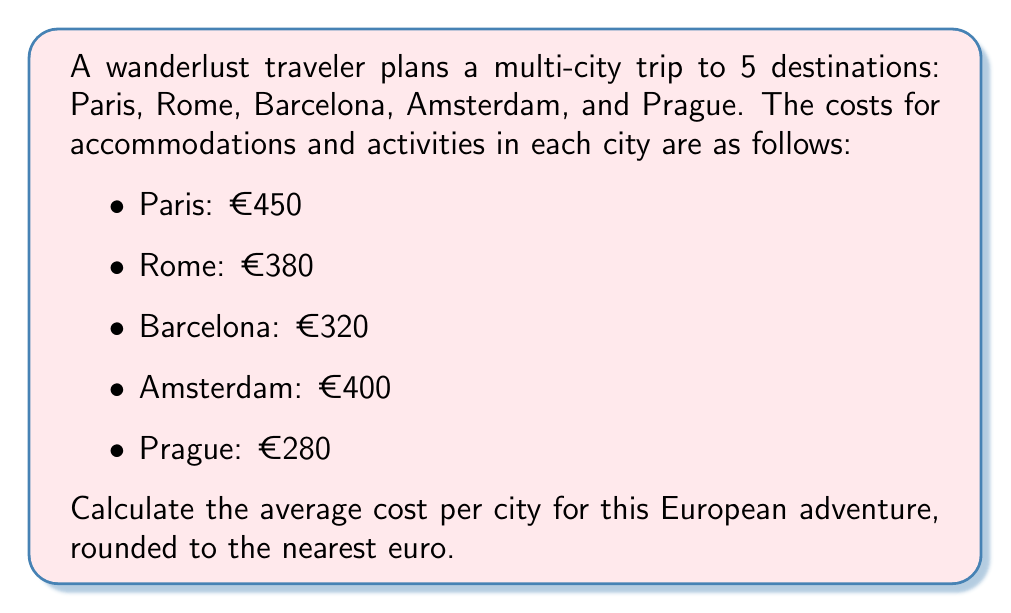Could you help me with this problem? To calculate the average cost per city, we need to follow these steps:

1. Sum up the total costs for all cities:
   $$\text{Total Cost} = 450 + 380 + 320 + 400 + 280 = €1830$$

2. Count the number of cities:
   $$\text{Number of Cities} = 5$$

3. Calculate the average cost per city using the formula:
   $$\text{Average Cost} = \frac{\text{Total Cost}}{\text{Number of Cities}}$$

4. Substitute the values:
   $$\text{Average Cost} = \frac{1830}{5} = €366$$

5. Round to the nearest euro:
   $$\text{Rounded Average Cost} = €366$$

Therefore, the average cost per city for this multi-city European trip is €366.
Answer: €366 